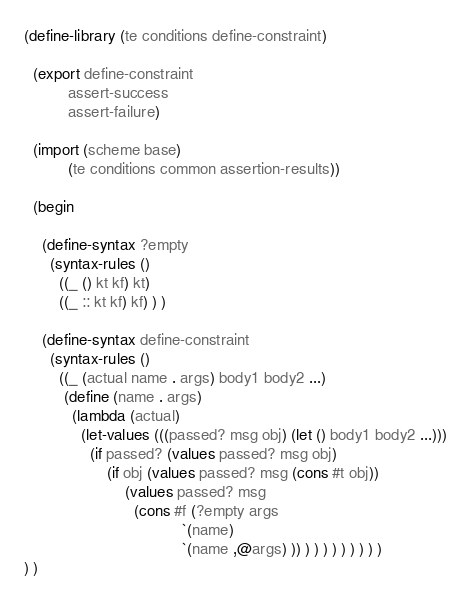Convert code to text. <code><loc_0><loc_0><loc_500><loc_500><_Scheme_>(define-library (te conditions define-constraint)

  (export define-constraint
          assert-success
          assert-failure)

  (import (scheme base)
          (te conditions common assertion-results))

  (begin

    (define-syntax ?empty
      (syntax-rules ()
        ((_ () kt kf) kt)
        ((_ :: kt kf) kf) ) )

    (define-syntax define-constraint
      (syntax-rules ()
        ((_ (actual name . args) body1 body2 ...)
         (define (name . args)
           (lambda (actual)
             (let-values (((passed? msg obj) (let () body1 body2 ...)))
               (if passed? (values passed? msg obj)
                   (if obj (values passed? msg (cons #t obj))
                       (values passed? msg
                         (cons #f (?empty args
                                    `(name)
                                    `(name ,@args) )) ) ) ) ) ) ) ) ) )
) )
</code> 